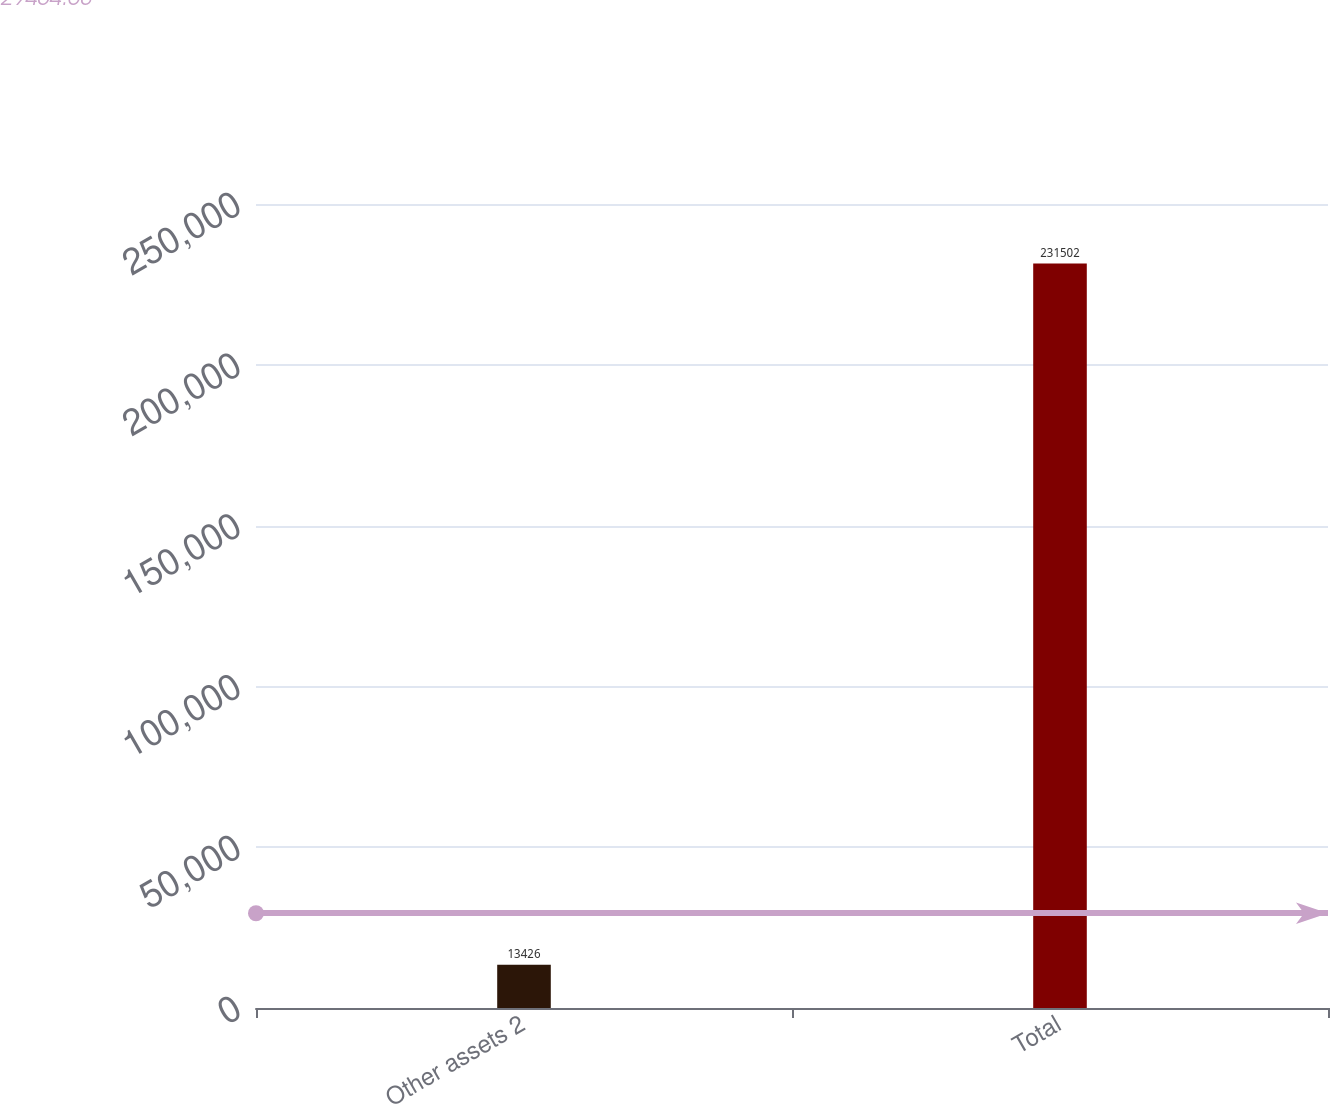Convert chart. <chart><loc_0><loc_0><loc_500><loc_500><bar_chart><fcel>Other assets 2<fcel>Total<nl><fcel>13426<fcel>231502<nl></chart> 